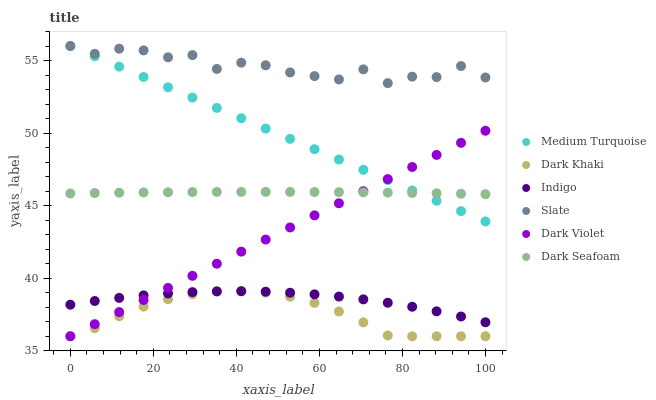Does Dark Khaki have the minimum area under the curve?
Answer yes or no. Yes. Does Slate have the maximum area under the curve?
Answer yes or no. Yes. Does Dark Violet have the minimum area under the curve?
Answer yes or no. No. Does Dark Violet have the maximum area under the curve?
Answer yes or no. No. Is Dark Violet the smoothest?
Answer yes or no. Yes. Is Slate the roughest?
Answer yes or no. Yes. Is Slate the smoothest?
Answer yes or no. No. Is Dark Violet the roughest?
Answer yes or no. No. Does Dark Violet have the lowest value?
Answer yes or no. Yes. Does Slate have the lowest value?
Answer yes or no. No. Does Medium Turquoise have the highest value?
Answer yes or no. Yes. Does Dark Violet have the highest value?
Answer yes or no. No. Is Dark Khaki less than Dark Seafoam?
Answer yes or no. Yes. Is Medium Turquoise greater than Dark Khaki?
Answer yes or no. Yes. Does Dark Violet intersect Indigo?
Answer yes or no. Yes. Is Dark Violet less than Indigo?
Answer yes or no. No. Is Dark Violet greater than Indigo?
Answer yes or no. No. Does Dark Khaki intersect Dark Seafoam?
Answer yes or no. No. 